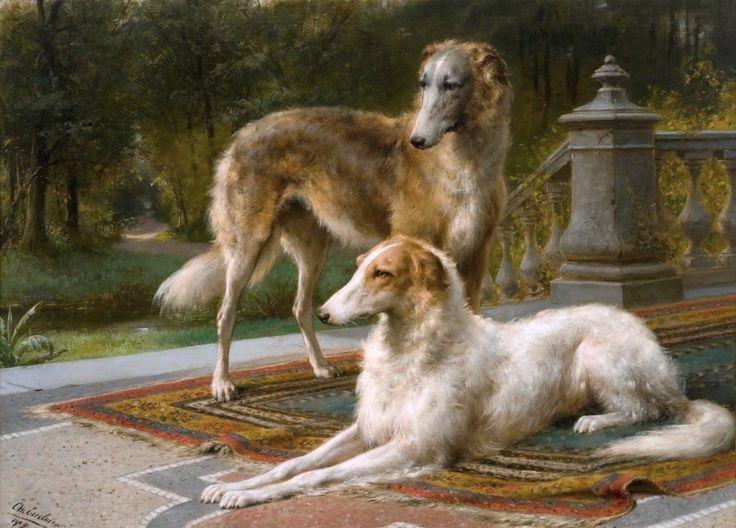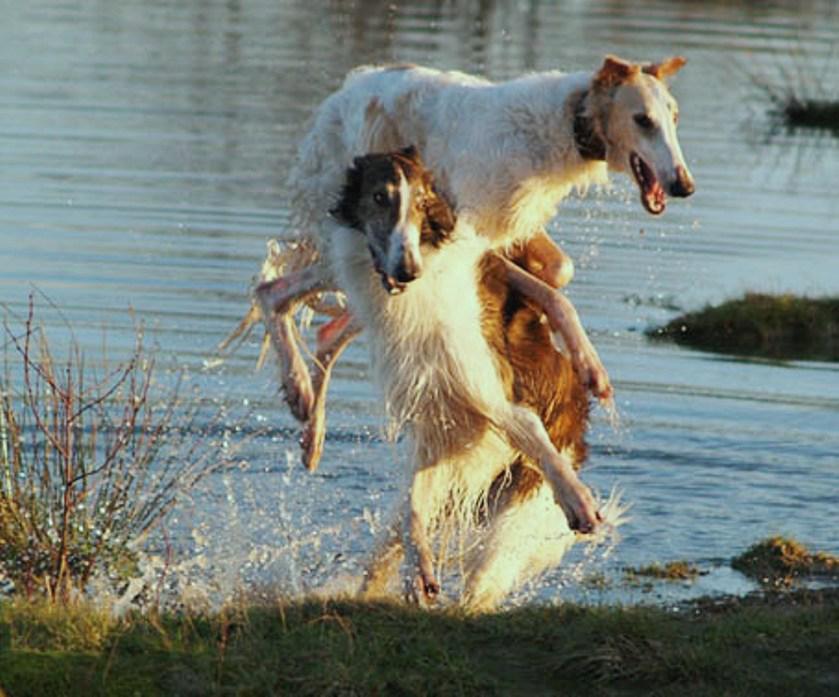The first image is the image on the left, the second image is the image on the right. For the images shown, is this caption "A woman is sitting with her two dogs." true? Answer yes or no. No. The first image is the image on the left, the second image is the image on the right. Analyze the images presented: Is the assertion "A woman is sitting with her two dogs nearby." valid? Answer yes or no. No. 